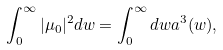<formula> <loc_0><loc_0><loc_500><loc_500>\int _ { 0 } ^ { \infty } | \mu _ { 0 } | ^ { 2 } d w = \int _ { 0 } ^ { \infty } d w a ^ { 3 } ( w ) ,</formula> 